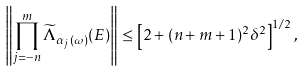<formula> <loc_0><loc_0><loc_500><loc_500>\left \| \prod _ { j = - n } ^ { m } \widetilde { \Lambda } _ { \alpha _ { j } ( \omega ) } ( E ) \right \| \leq \left [ 2 + ( n + m + 1 ) ^ { 2 } \delta ^ { 2 } \right ] ^ { 1 / 2 } ,</formula> 